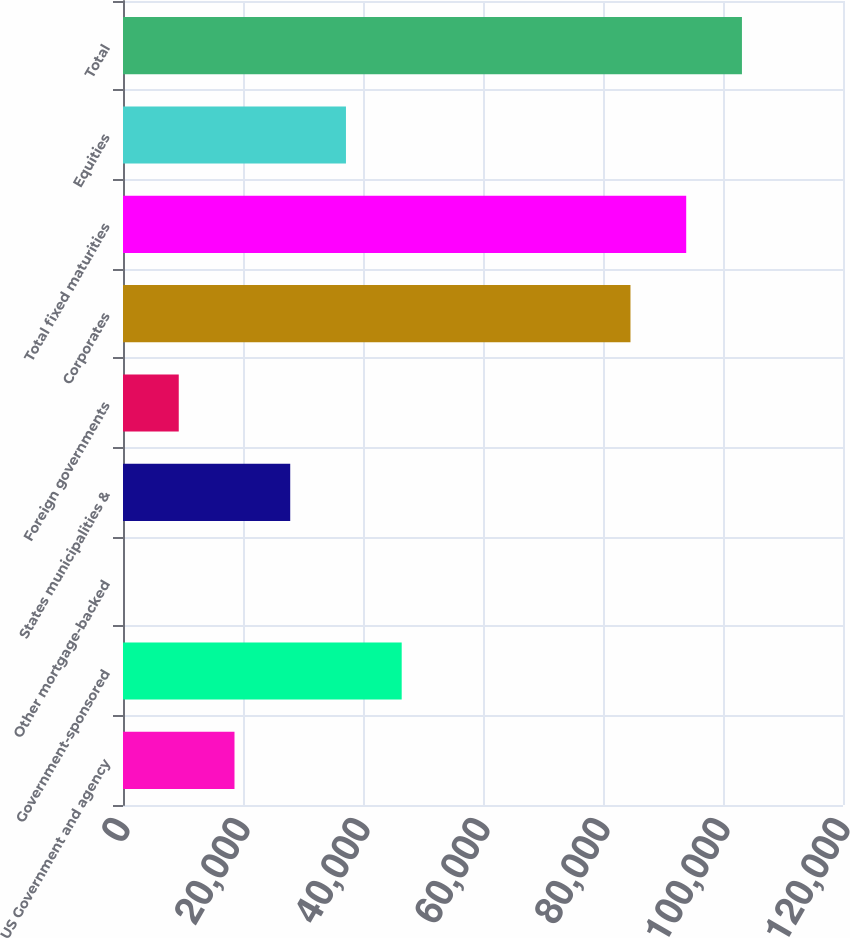<chart> <loc_0><loc_0><loc_500><loc_500><bar_chart><fcel>US Government and agency<fcel>Government-sponsored<fcel>Other mortgage-backed<fcel>States municipalities &<fcel>Foreign governments<fcel>Corporates<fcel>Total fixed maturities<fcel>Equities<fcel>Total<nl><fcel>18581.8<fcel>46449.6<fcel>3.22<fcel>27871.1<fcel>9292.5<fcel>84578<fcel>93867.3<fcel>37160.3<fcel>103157<nl></chart> 